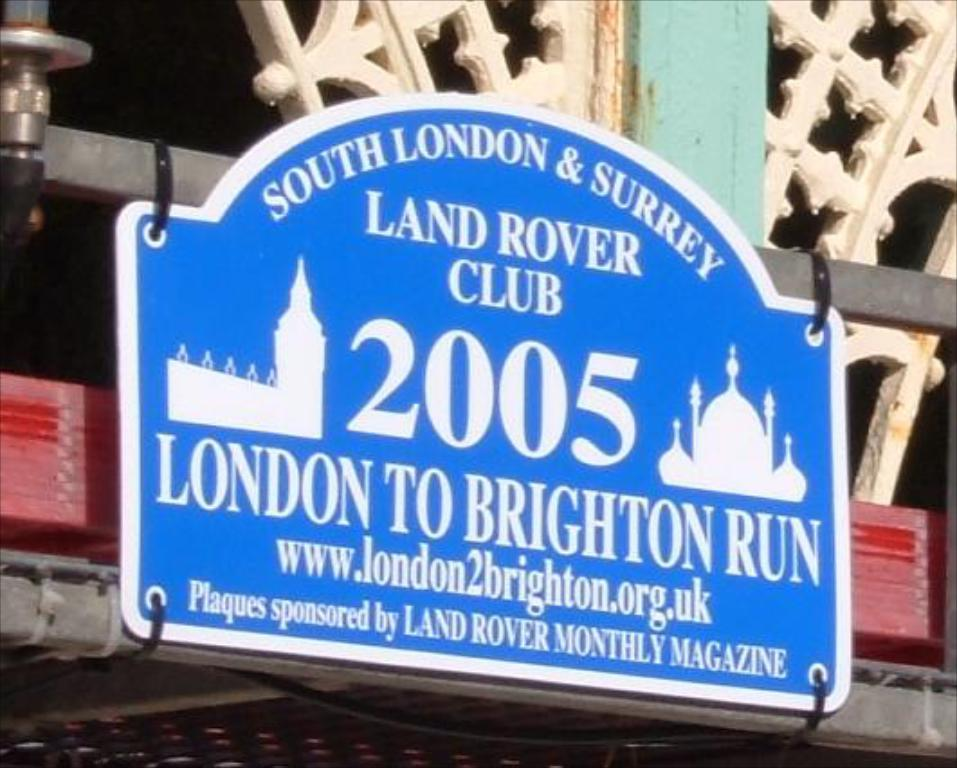<image>
Offer a succinct explanation of the picture presented. Sign that says south london and surrey land rover club 2005 